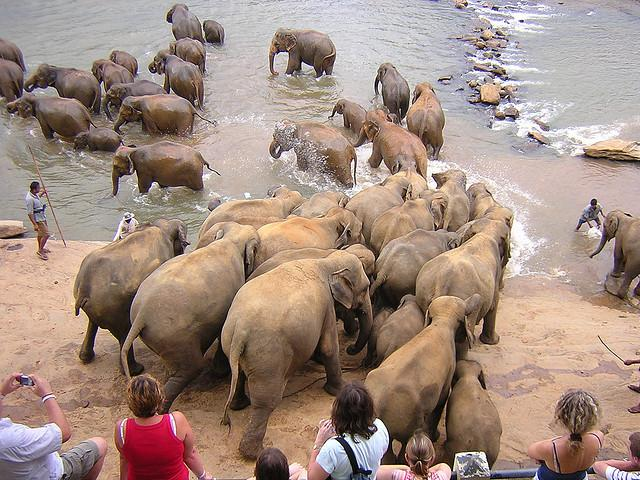Why is the man holding a camera? Please explain your reasoning. taking pictures. To have everlasting memories of the vacation 